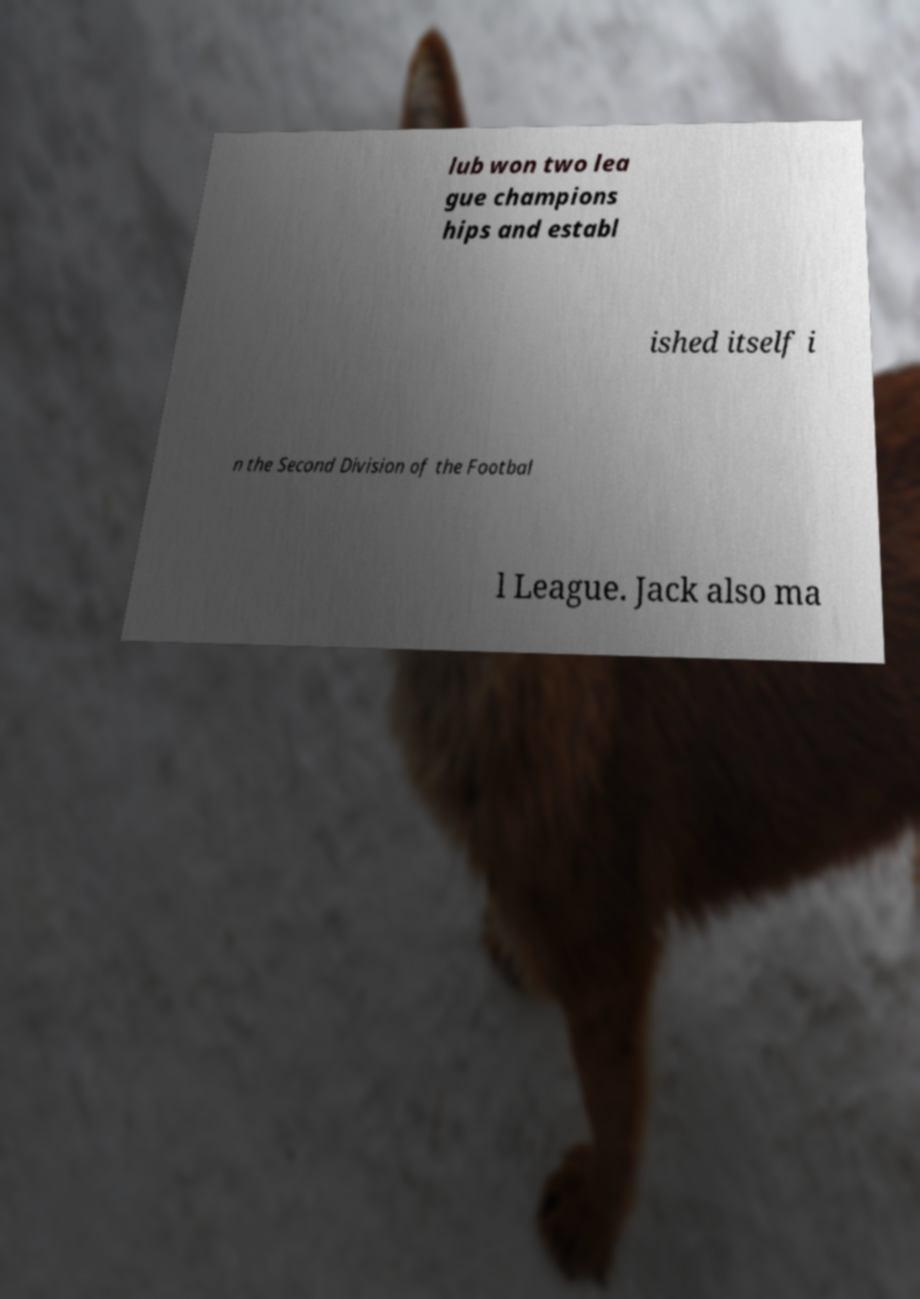What messages or text are displayed in this image? I need them in a readable, typed format. lub won two lea gue champions hips and establ ished itself i n the Second Division of the Footbal l League. Jack also ma 